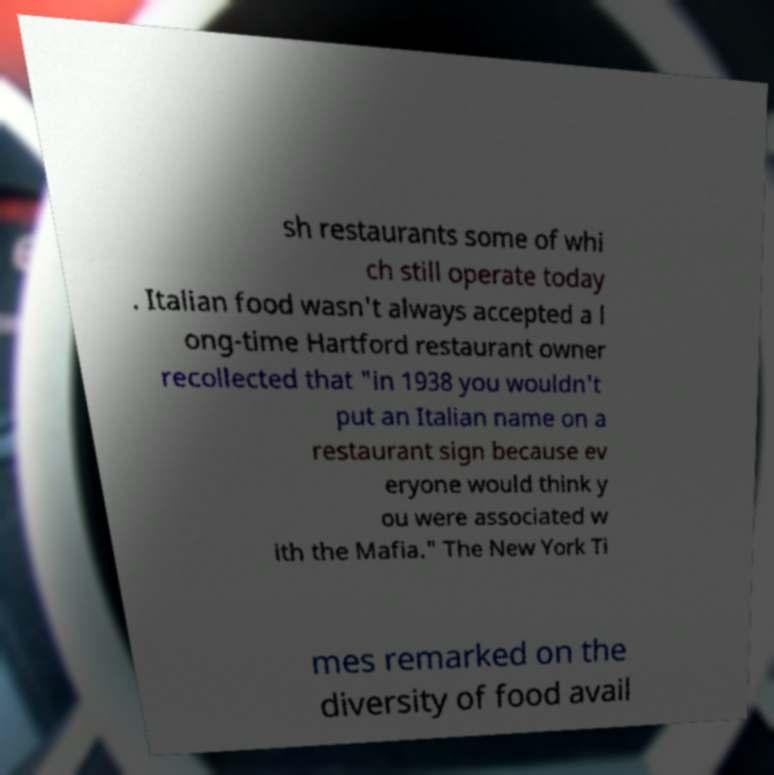There's text embedded in this image that I need extracted. Can you transcribe it verbatim? sh restaurants some of whi ch still operate today . Italian food wasn't always accepted a l ong-time Hartford restaurant owner recollected that "in 1938 you wouldn't put an Italian name on a restaurant sign because ev eryone would think y ou were associated w ith the Mafia." The New York Ti mes remarked on the diversity of food avail 